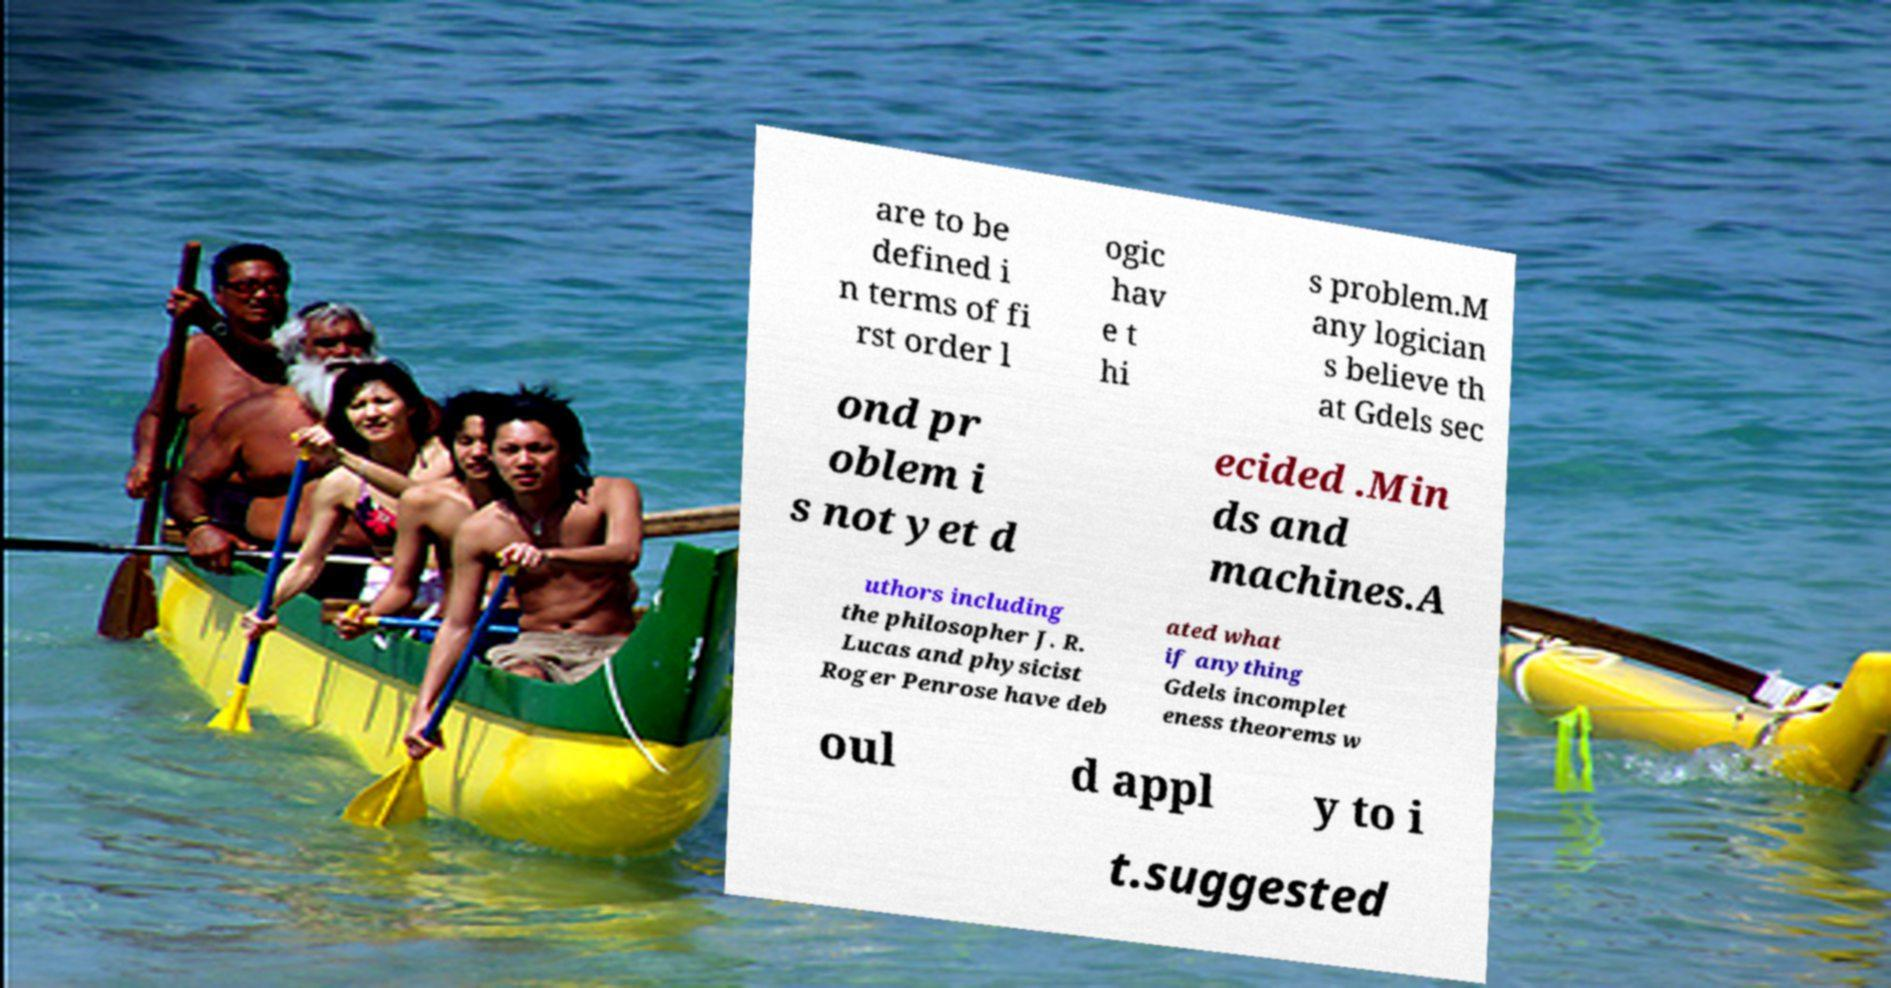Can you read and provide the text displayed in the image?This photo seems to have some interesting text. Can you extract and type it out for me? are to be defined i n terms of fi rst order l ogic hav e t hi s problem.M any logician s believe th at Gdels sec ond pr oblem i s not yet d ecided .Min ds and machines.A uthors including the philosopher J. R. Lucas and physicist Roger Penrose have deb ated what if anything Gdels incomplet eness theorems w oul d appl y to i t.suggested 